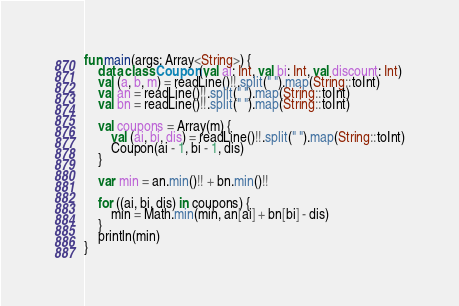Convert code to text. <code><loc_0><loc_0><loc_500><loc_500><_Kotlin_>fun main(args: Array<String>) {
    data class Coupon(val ai: Int, val bi: Int, val discount: Int)
    val (a, b, m) = readLine()!!.split(" ").map(String::toInt)
    val an = readLine()!!.split(" ").map(String::toInt)
    val bn = readLine()!!.split(" ").map(String::toInt)

    val coupons = Array(m) {
        val (ai, bi, dis) = readLine()!!.split(" ").map(String::toInt)
        Coupon(ai - 1, bi - 1, dis)
    }

    var min = an.min()!! + bn.min()!!

    for ((ai, bi, dis) in coupons) {
        min = Math.min(min, an[ai] + bn[bi] - dis)
    }
    println(min)
}



</code> 